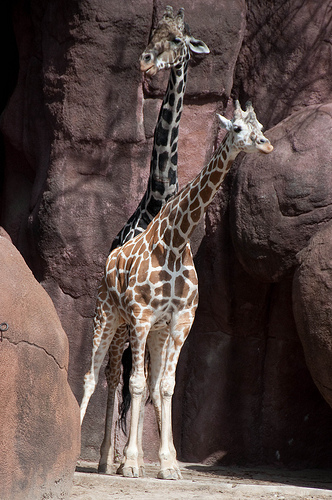<image>
Can you confirm if the giraffe is in the exhibit? Yes. The giraffe is contained within or inside the exhibit, showing a containment relationship. 